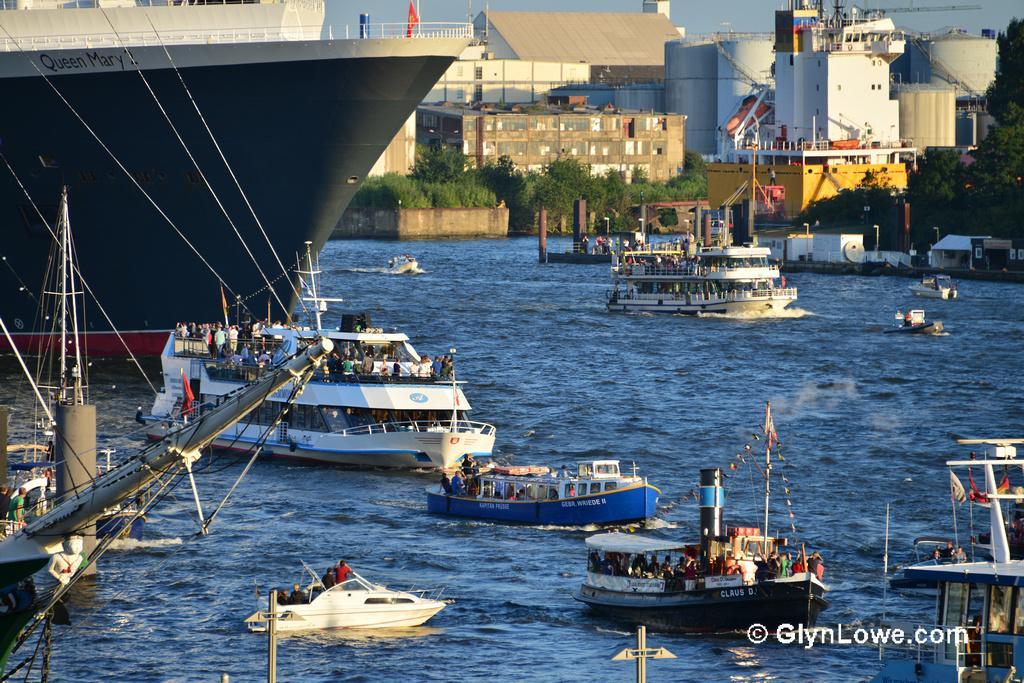How would you summarize this image in a sentence or two? In this image I can see water and boats in it. I can see number of people in boats. Here I can see a ship, number of trees and buildings. 